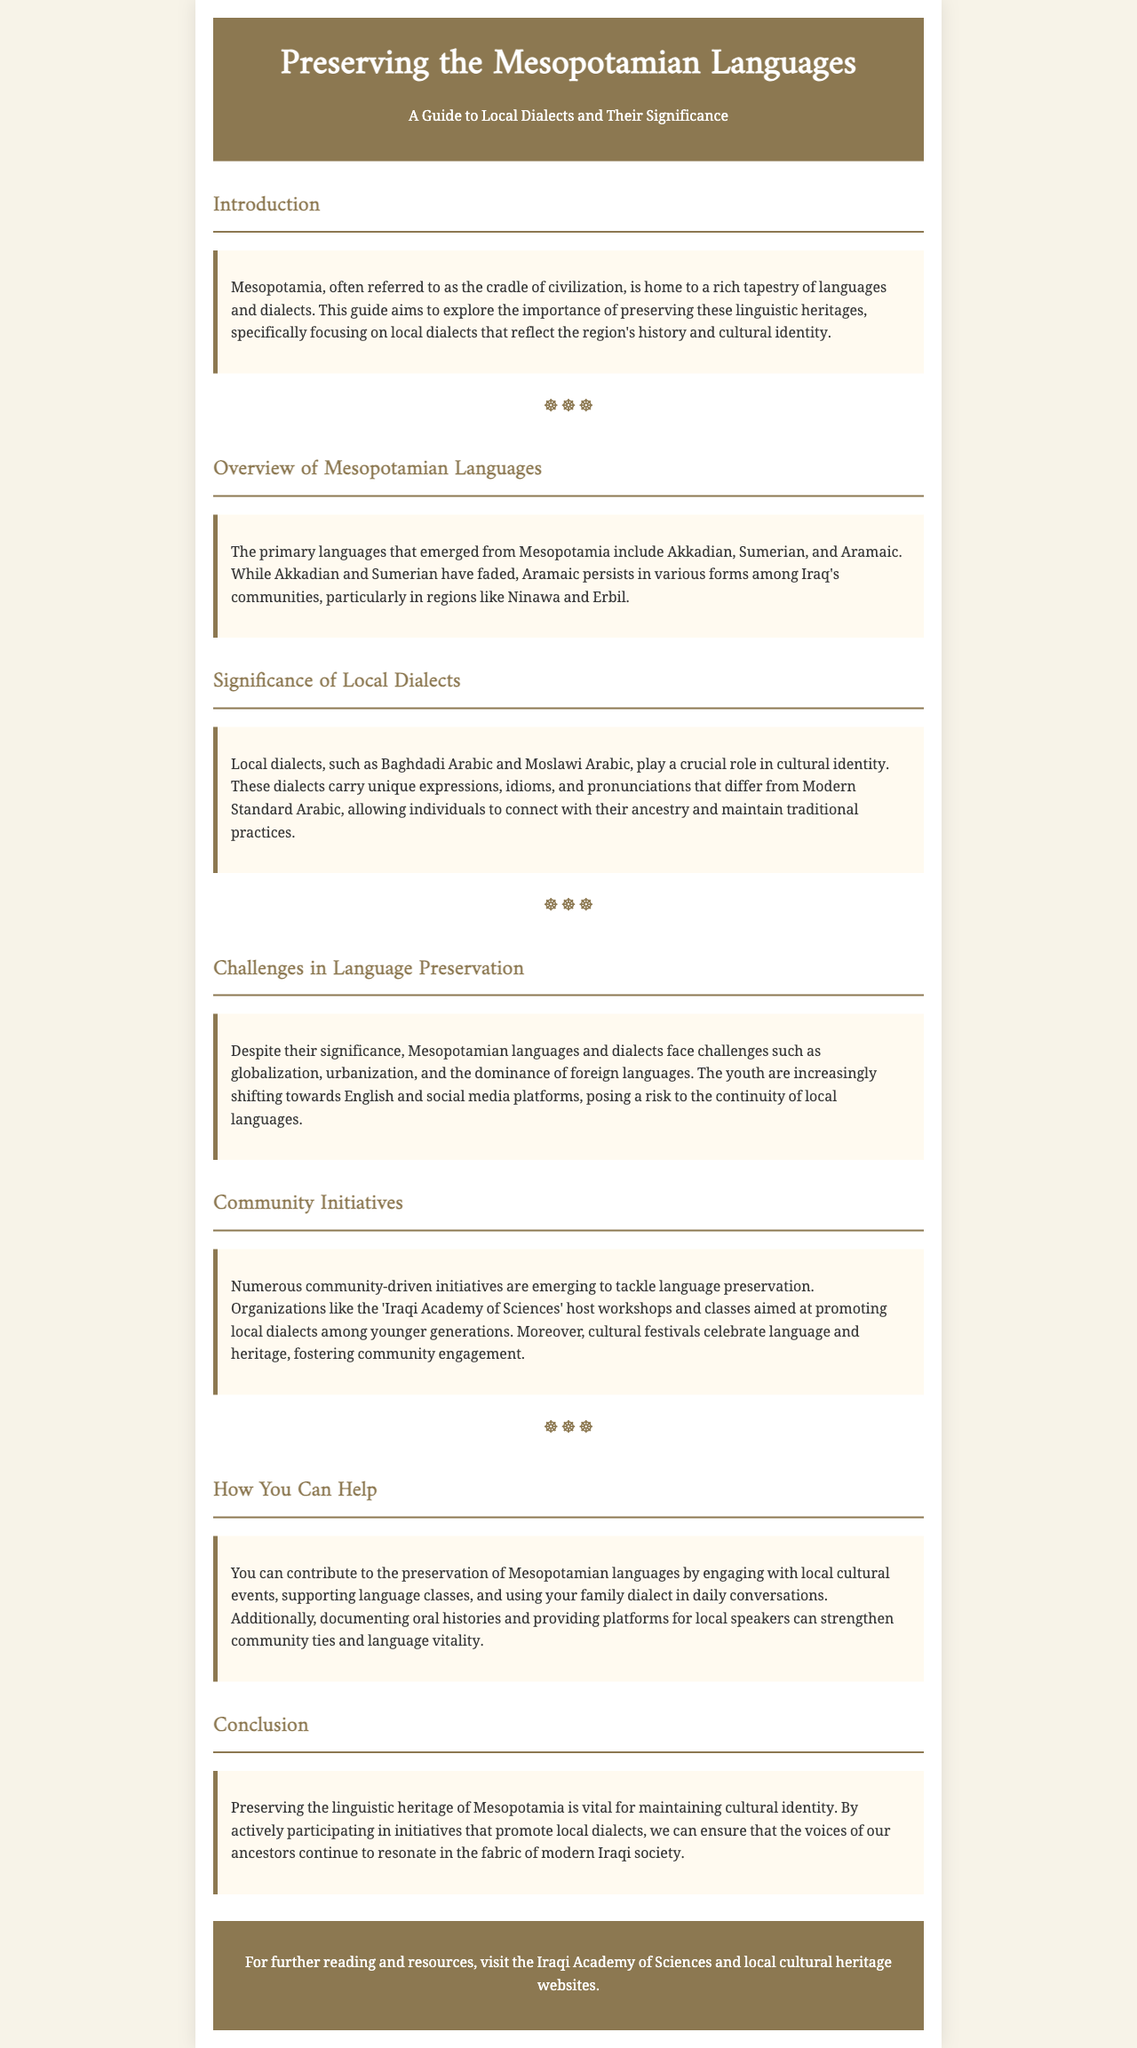What is the primary focus of the guide? The guide aims to explore the importance of preserving Mesopotamian linguistic heritages, specifically local dialects.
Answer: Preserving Mesopotamian linguistic heritages What are the three primary languages mentioned? The document lists the primary languages that emerged from Mesopotamia.
Answer: Akkadian, Sumerian, and Aramaic Which dialects are specifically noted for cultural identity? The section discusses local dialects that play a crucial role in cultural identity.
Answer: Baghdadi Arabic and Moslawi Arabic What challenges do Mesopotamian languages face? The document highlights issues affecting language preservation.
Answer: Globalization, urbanization, and the dominance of foreign languages What organization hosts workshops for language promotion? A specific organization mentioned in the document that aims to promote local dialects among younger generations.
Answer: Iraqi Academy of Sciences What can individuals do to help preserve these languages? The document suggests ways individuals can contribute to language preservation.
Answer: Engage with local cultural events, support language classes What is the overall goal of preserving Mesopotamian languages? The conclusion addresses the overarching goal related to cultural identity.
Answer: Maintaining cultural identity 